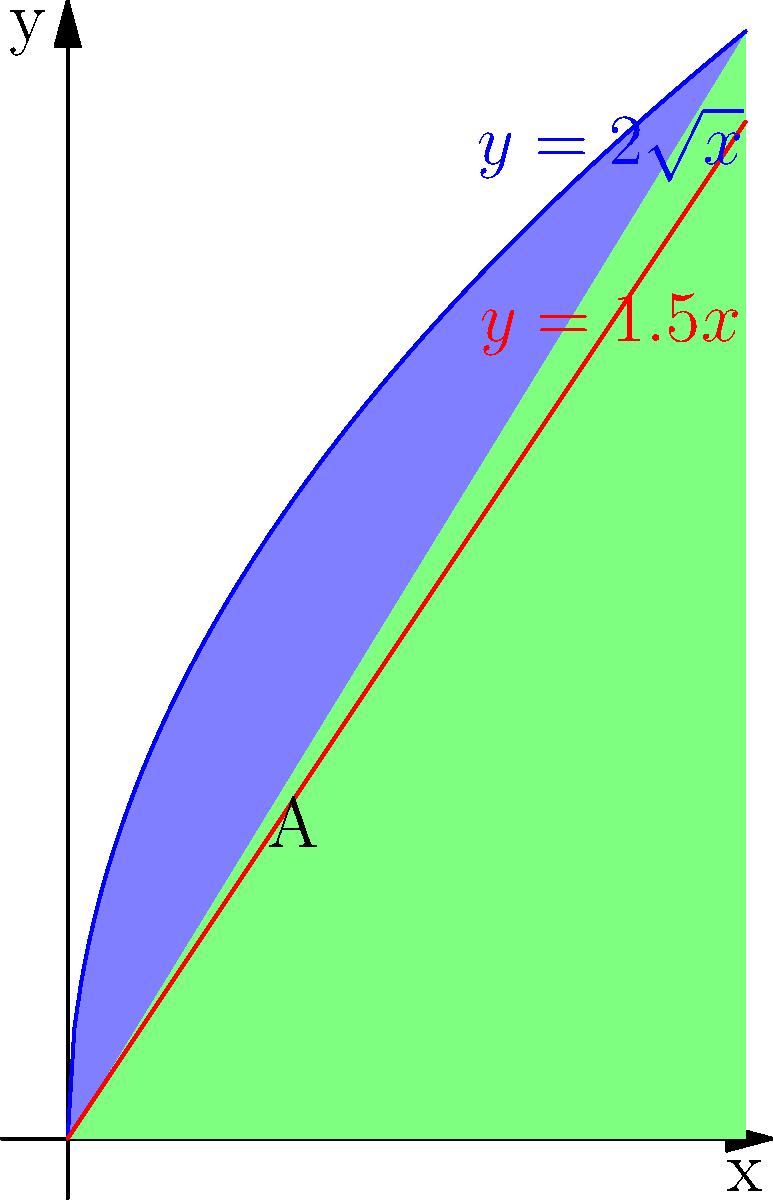An ancient African artifact has an irregular shape that can be modeled by the region bounded by the curves $y=2\sqrt{x}$, $y=1.5x$, and the y-axis. Calculate the area of this artifact using integration. Round your answer to two decimal places. To find the area of the irregularly shaped artifact, we need to integrate the difference between the two functions over the appropriate interval:

1) First, find the intersection point of the two curves:
   $2\sqrt{x} = 1.5x$
   $4x = 2.25x^2$
   $2.25x^2 - 4x = 0$
   $x(2.25x - 4) = 0$
   $x = 0$ or $x = \frac{16}{9} \approx 1.78$

2) The area is given by the integral:
   $$A = \int_{0}^{\frac{16}{9}} (2\sqrt{x} - 1.5x) dx$$

3) Integrate:
   $$A = \left[\frac{4}{3}x^{\frac{3}{2}} - \frac{3}{4}x^2\right]_{0}^{\frac{16}{9}}$$

4) Evaluate the integral:
   $$A = \left(\frac{4}{3}\left(\frac{16}{9}\right)^{\frac{3}{2}} - \frac{3}{4}\left(\frac{16}{9}\right)^2\right) - \left(\frac{4}{3}(0)^{\frac{3}{2}} - \frac{3}{4}(0)^2\right)$$
   $$A = \left(\frac{4}{3}\cdot\frac{64}{27} - \frac{3}{4}\cdot\frac{256}{81}\right) - 0$$
   $$A = \frac{256}{81} - \frac{64}{27} = \frac{256}{81} - \frac{192}{81} = \frac{64}{81}$$

5) Convert to decimal and round to two decimal places:
   $$A \approx 0.79$$

Therefore, the area of the artifact is approximately 0.79 square units.
Answer: 0.79 square units 